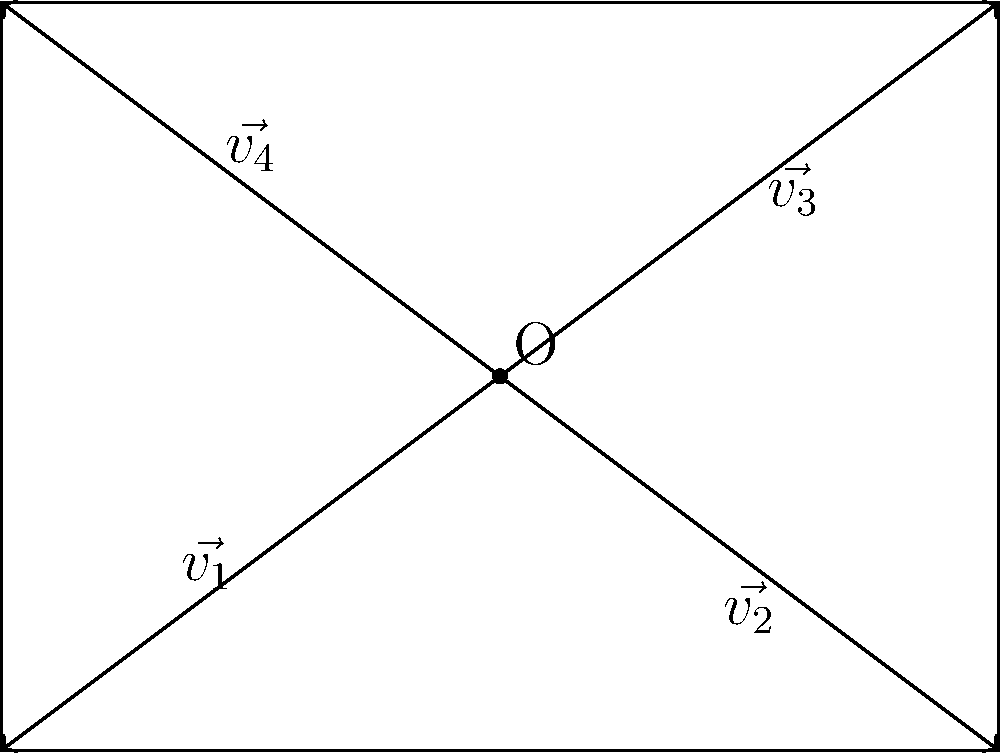As a community lawyer advocating for public safety regulations, you're tasked with determining the optimal placement of traffic signals at a four-way intersection. The intersection is represented by vectors $\vec{v_1}$, $\vec{v_2}$, $\vec{v_3}$, and $\vec{v_4}$ from the center point O to each corner. If the angles between adjacent vectors are all equal, what is the measure of the angle between any two adjacent vectors? To determine the optimal placement of traffic signals, we need to consider the symmetry of the intersection. Let's approach this step-by-step:

1) In a four-way intersection, there are four vectors from the center point to each corner.

2) The vectors form a complete rotation around the center point O.

3) A complete rotation is 360°.

4) We're told that the angles between adjacent vectors are all equal.

5) To find the measure of each angle, we need to divide the total rotation by the number of equal parts:

   $\text{Angle measure} = \frac{\text{Total rotation}}{\text{Number of equal parts}}$

6) In this case:
   $\text{Angle measure} = \frac{360°}{4} = 90°$

7) This result indicates that the vectors form right angles with each other, creating a perfect square or rectangle shape for the intersection.

This symmetrical arrangement ensures equal visibility and timing for traffic signals in all directions, promoting optimal traffic flow and safety.
Answer: 90° 